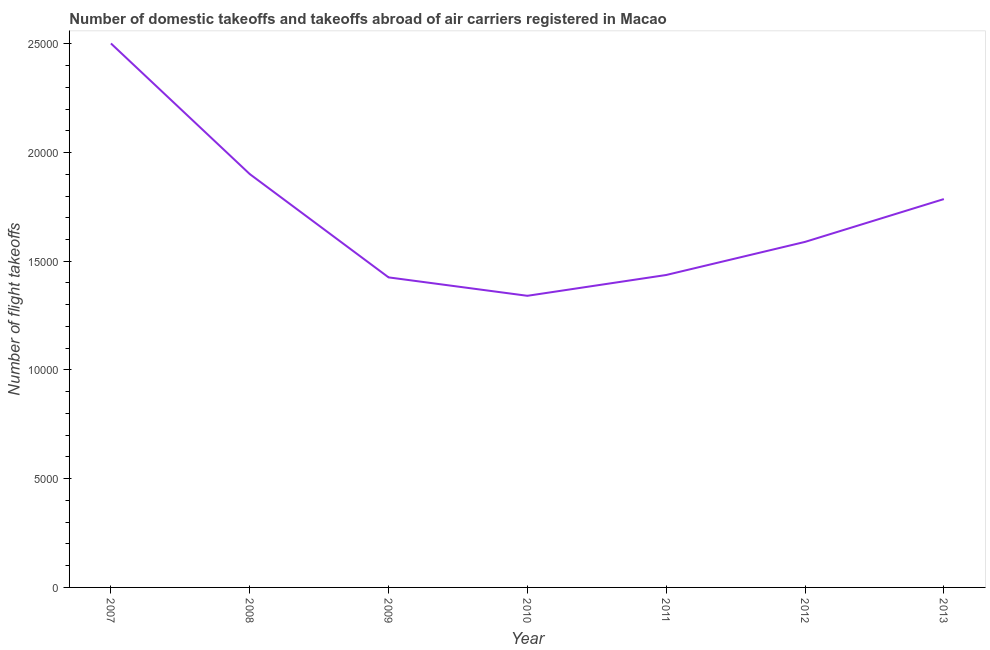What is the number of flight takeoffs in 2010?
Make the answer very short. 1.34e+04. Across all years, what is the maximum number of flight takeoffs?
Provide a succinct answer. 2.50e+04. Across all years, what is the minimum number of flight takeoffs?
Provide a succinct answer. 1.34e+04. What is the sum of the number of flight takeoffs?
Your answer should be compact. 1.20e+05. What is the difference between the number of flight takeoffs in 2008 and 2012?
Your answer should be very brief. 3119. What is the average number of flight takeoffs per year?
Provide a succinct answer. 1.71e+04. What is the median number of flight takeoffs?
Offer a terse response. 1.59e+04. In how many years, is the number of flight takeoffs greater than 4000 ?
Provide a succinct answer. 7. Do a majority of the years between 2007 and 2008 (inclusive) have number of flight takeoffs greater than 4000 ?
Your answer should be very brief. Yes. What is the ratio of the number of flight takeoffs in 2009 to that in 2013?
Offer a terse response. 0.8. Is the number of flight takeoffs in 2010 less than that in 2013?
Your response must be concise. Yes. Is the difference between the number of flight takeoffs in 2007 and 2012 greater than the difference between any two years?
Make the answer very short. No. What is the difference between the highest and the second highest number of flight takeoffs?
Keep it short and to the point. 6007. Is the sum of the number of flight takeoffs in 2008 and 2009 greater than the maximum number of flight takeoffs across all years?
Your answer should be very brief. Yes. What is the difference between the highest and the lowest number of flight takeoffs?
Ensure brevity in your answer.  1.16e+04. In how many years, is the number of flight takeoffs greater than the average number of flight takeoffs taken over all years?
Your response must be concise. 3. How many lines are there?
Provide a succinct answer. 1. What is the difference between two consecutive major ticks on the Y-axis?
Provide a succinct answer. 5000. Does the graph contain any zero values?
Offer a very short reply. No. What is the title of the graph?
Make the answer very short. Number of domestic takeoffs and takeoffs abroad of air carriers registered in Macao. What is the label or title of the X-axis?
Offer a terse response. Year. What is the label or title of the Y-axis?
Make the answer very short. Number of flight takeoffs. What is the Number of flight takeoffs of 2007?
Offer a very short reply. 2.50e+04. What is the Number of flight takeoffs of 2008?
Keep it short and to the point. 1.90e+04. What is the Number of flight takeoffs of 2009?
Offer a terse response. 1.43e+04. What is the Number of flight takeoffs in 2010?
Offer a terse response. 1.34e+04. What is the Number of flight takeoffs of 2011?
Your answer should be very brief. 1.44e+04. What is the Number of flight takeoffs of 2012?
Keep it short and to the point. 1.59e+04. What is the Number of flight takeoffs in 2013?
Provide a succinct answer. 1.79e+04. What is the difference between the Number of flight takeoffs in 2007 and 2008?
Offer a very short reply. 6007. What is the difference between the Number of flight takeoffs in 2007 and 2009?
Ensure brevity in your answer.  1.08e+04. What is the difference between the Number of flight takeoffs in 2007 and 2010?
Your answer should be compact. 1.16e+04. What is the difference between the Number of flight takeoffs in 2007 and 2011?
Give a very brief answer. 1.06e+04. What is the difference between the Number of flight takeoffs in 2007 and 2012?
Your answer should be compact. 9126. What is the difference between the Number of flight takeoffs in 2007 and 2013?
Your answer should be compact. 7157. What is the difference between the Number of flight takeoffs in 2008 and 2009?
Offer a terse response. 4751. What is the difference between the Number of flight takeoffs in 2008 and 2010?
Offer a terse response. 5598. What is the difference between the Number of flight takeoffs in 2008 and 2011?
Offer a very short reply. 4641. What is the difference between the Number of flight takeoffs in 2008 and 2012?
Make the answer very short. 3119. What is the difference between the Number of flight takeoffs in 2008 and 2013?
Offer a very short reply. 1150. What is the difference between the Number of flight takeoffs in 2009 and 2010?
Your answer should be compact. 847. What is the difference between the Number of flight takeoffs in 2009 and 2011?
Your response must be concise. -110. What is the difference between the Number of flight takeoffs in 2009 and 2012?
Provide a short and direct response. -1632. What is the difference between the Number of flight takeoffs in 2009 and 2013?
Provide a short and direct response. -3601. What is the difference between the Number of flight takeoffs in 2010 and 2011?
Keep it short and to the point. -957. What is the difference between the Number of flight takeoffs in 2010 and 2012?
Offer a terse response. -2479. What is the difference between the Number of flight takeoffs in 2010 and 2013?
Provide a succinct answer. -4448. What is the difference between the Number of flight takeoffs in 2011 and 2012?
Keep it short and to the point. -1522. What is the difference between the Number of flight takeoffs in 2011 and 2013?
Ensure brevity in your answer.  -3491. What is the difference between the Number of flight takeoffs in 2012 and 2013?
Your answer should be very brief. -1969. What is the ratio of the Number of flight takeoffs in 2007 to that in 2008?
Make the answer very short. 1.32. What is the ratio of the Number of flight takeoffs in 2007 to that in 2009?
Make the answer very short. 1.75. What is the ratio of the Number of flight takeoffs in 2007 to that in 2010?
Provide a succinct answer. 1.86. What is the ratio of the Number of flight takeoffs in 2007 to that in 2011?
Provide a succinct answer. 1.74. What is the ratio of the Number of flight takeoffs in 2007 to that in 2012?
Your answer should be very brief. 1.57. What is the ratio of the Number of flight takeoffs in 2007 to that in 2013?
Offer a terse response. 1.4. What is the ratio of the Number of flight takeoffs in 2008 to that in 2009?
Your answer should be very brief. 1.33. What is the ratio of the Number of flight takeoffs in 2008 to that in 2010?
Provide a short and direct response. 1.42. What is the ratio of the Number of flight takeoffs in 2008 to that in 2011?
Your answer should be very brief. 1.32. What is the ratio of the Number of flight takeoffs in 2008 to that in 2012?
Give a very brief answer. 1.2. What is the ratio of the Number of flight takeoffs in 2008 to that in 2013?
Your response must be concise. 1.06. What is the ratio of the Number of flight takeoffs in 2009 to that in 2010?
Make the answer very short. 1.06. What is the ratio of the Number of flight takeoffs in 2009 to that in 2012?
Your response must be concise. 0.9. What is the ratio of the Number of flight takeoffs in 2009 to that in 2013?
Make the answer very short. 0.8. What is the ratio of the Number of flight takeoffs in 2010 to that in 2011?
Make the answer very short. 0.93. What is the ratio of the Number of flight takeoffs in 2010 to that in 2012?
Make the answer very short. 0.84. What is the ratio of the Number of flight takeoffs in 2010 to that in 2013?
Your answer should be compact. 0.75. What is the ratio of the Number of flight takeoffs in 2011 to that in 2012?
Ensure brevity in your answer.  0.9. What is the ratio of the Number of flight takeoffs in 2011 to that in 2013?
Keep it short and to the point. 0.81. What is the ratio of the Number of flight takeoffs in 2012 to that in 2013?
Offer a terse response. 0.89. 